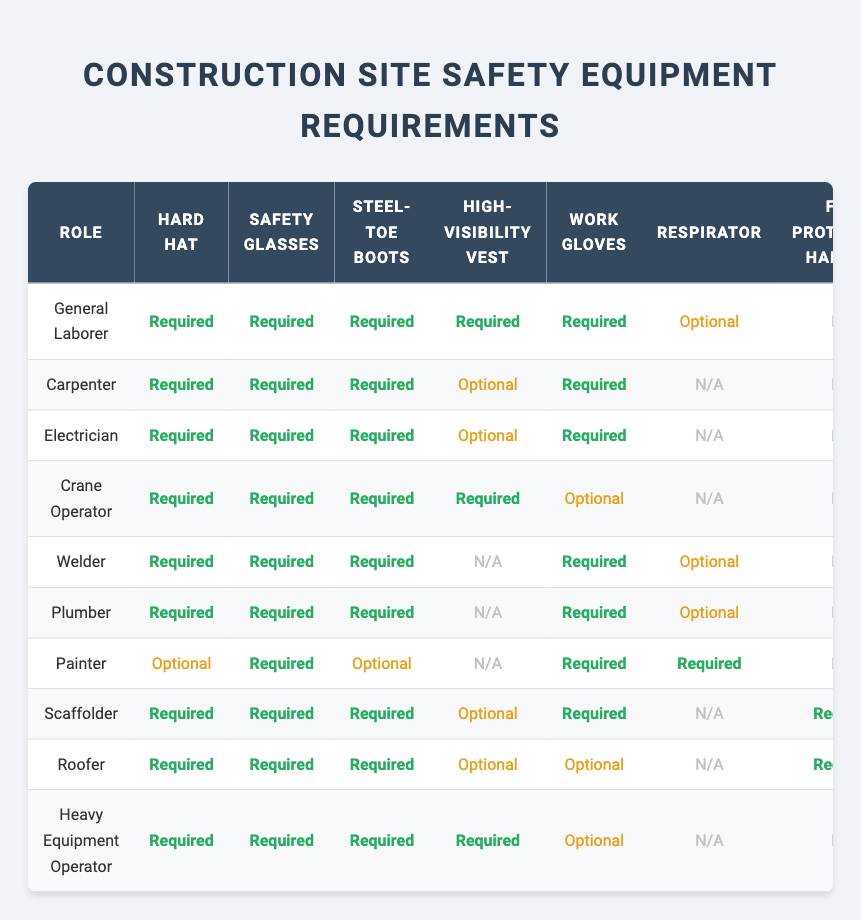What safety equipment is required for a Plumber? The table indicates that the required safety equipment for a Plumber includes a Hard Hat, Safety Glasses, Steel-Toe Boots, and Work Gloves.
Answer: Hard Hat, Safety Glasses, Steel-Toe Boots, Work Gloves Is a Fall Protection Harness required for a Painter? In the table, the required equipment for a Painter does not list a Fall Protection Harness, indicating that it is not required for this role.
Answer: No How many types of safety equipment are required by a Roofer? The required equipment for a Roofer includes four items: Hard Hat, Safety Glasses, Steel-Toe Boots, and Fall Protection Harness. Therefore, the total number is four.
Answer: 4 Which roles require a Respirator? By examining the table, we find that the roles that require a Respirator include Painter, Welder, and Plumber.
Answer: Painter, Welder, Plumber What is the difference in required safety equipment between a Carpenter and a Crane Operator? The Carpenter requires four items: Hard Hat, Safety Glasses, Steel-Toe Boots, and Work Gloves. The Crane Operator requires five items, similar to the Carpenter but also includes a High-Visibility Vest. Therefore, the difference is one additional item (the High-Visibility Vest) for the Crane Operator.
Answer: 1 (High-Visibility Vest) How many roles require Steel-Toe Boots? By reviewing the table, it's clear that every role listed requires Steel-Toe Boots, so counting all 10 roles gives us a total of ten.
Answer: 10 Are Hearing Protection and Fall Protection Harness required for the Electrician? Looking at the table, Hearing Protection is optional for the Electrician, while the Fall Protection Harness is marked as not applicable, which means neither is required.
Answer: No 